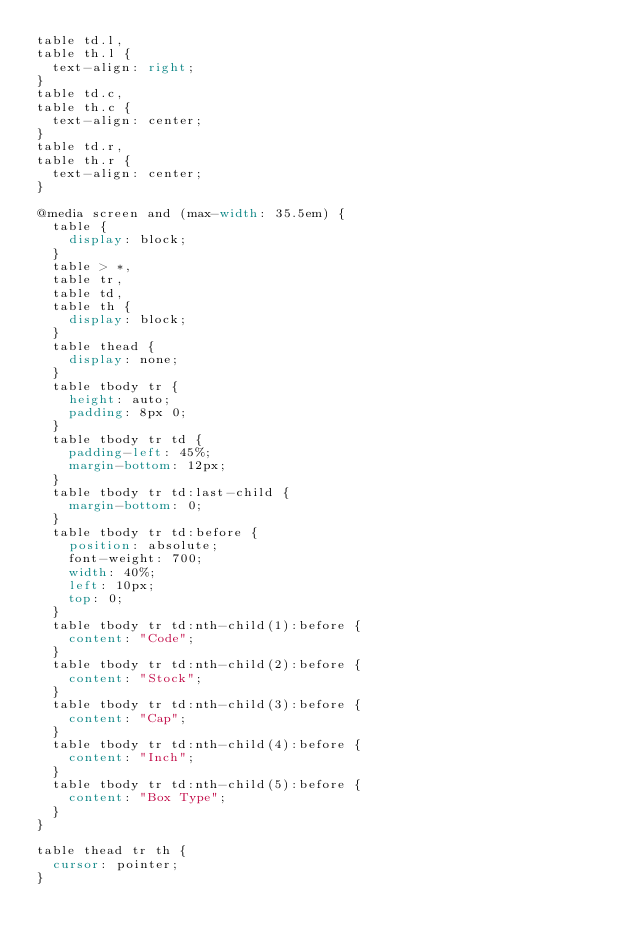Convert code to text. <code><loc_0><loc_0><loc_500><loc_500><_CSS_>table td.l,
table th.l {
  text-align: right;
}
table td.c,
table th.c {
  text-align: center;
}
table td.r,
table th.r {
  text-align: center;
}

@media screen and (max-width: 35.5em) {
  table {
    display: block;
  }
  table > *,
  table tr,
  table td,
  table th {
    display: block;
  }
  table thead {
    display: none;
  }
  table tbody tr {
    height: auto;
    padding: 8px 0;
  }
  table tbody tr td {
    padding-left: 45%;
    margin-bottom: 12px;
  }
  table tbody tr td:last-child {
    margin-bottom: 0;
  }
  table tbody tr td:before {
    position: absolute;
    font-weight: 700;
    width: 40%;
    left: 10px;
    top: 0;
  }
  table tbody tr td:nth-child(1):before {
    content: "Code";
  }
  table tbody tr td:nth-child(2):before {
    content: "Stock";
  }
  table tbody tr td:nth-child(3):before {
    content: "Cap";
  }
  table tbody tr td:nth-child(4):before {
    content: "Inch";
  }
  table tbody tr td:nth-child(5):before {
    content: "Box Type";
  }
}

table thead tr th {
  cursor: pointer;
}
</code> 